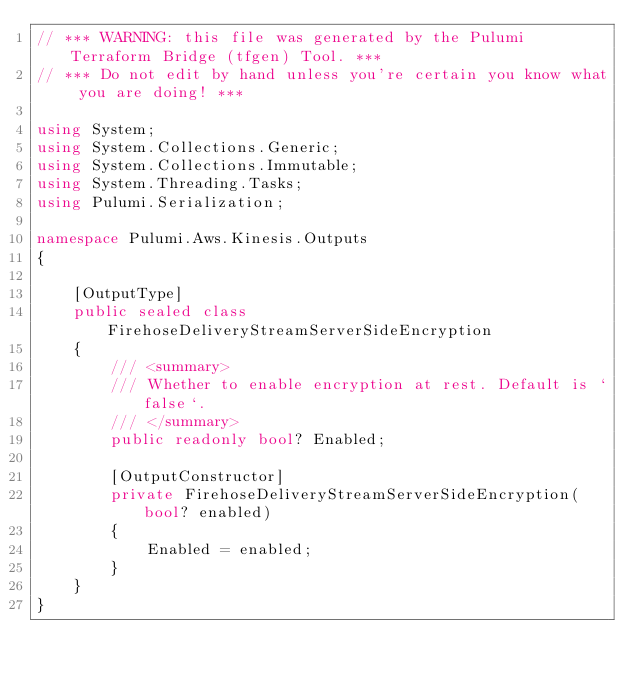<code> <loc_0><loc_0><loc_500><loc_500><_C#_>// *** WARNING: this file was generated by the Pulumi Terraform Bridge (tfgen) Tool. ***
// *** Do not edit by hand unless you're certain you know what you are doing! ***

using System;
using System.Collections.Generic;
using System.Collections.Immutable;
using System.Threading.Tasks;
using Pulumi.Serialization;

namespace Pulumi.Aws.Kinesis.Outputs
{

    [OutputType]
    public sealed class FirehoseDeliveryStreamServerSideEncryption
    {
        /// <summary>
        /// Whether to enable encryption at rest. Default is `false`.
        /// </summary>
        public readonly bool? Enabled;

        [OutputConstructor]
        private FirehoseDeliveryStreamServerSideEncryption(bool? enabled)
        {
            Enabled = enabled;
        }
    }
}
</code> 